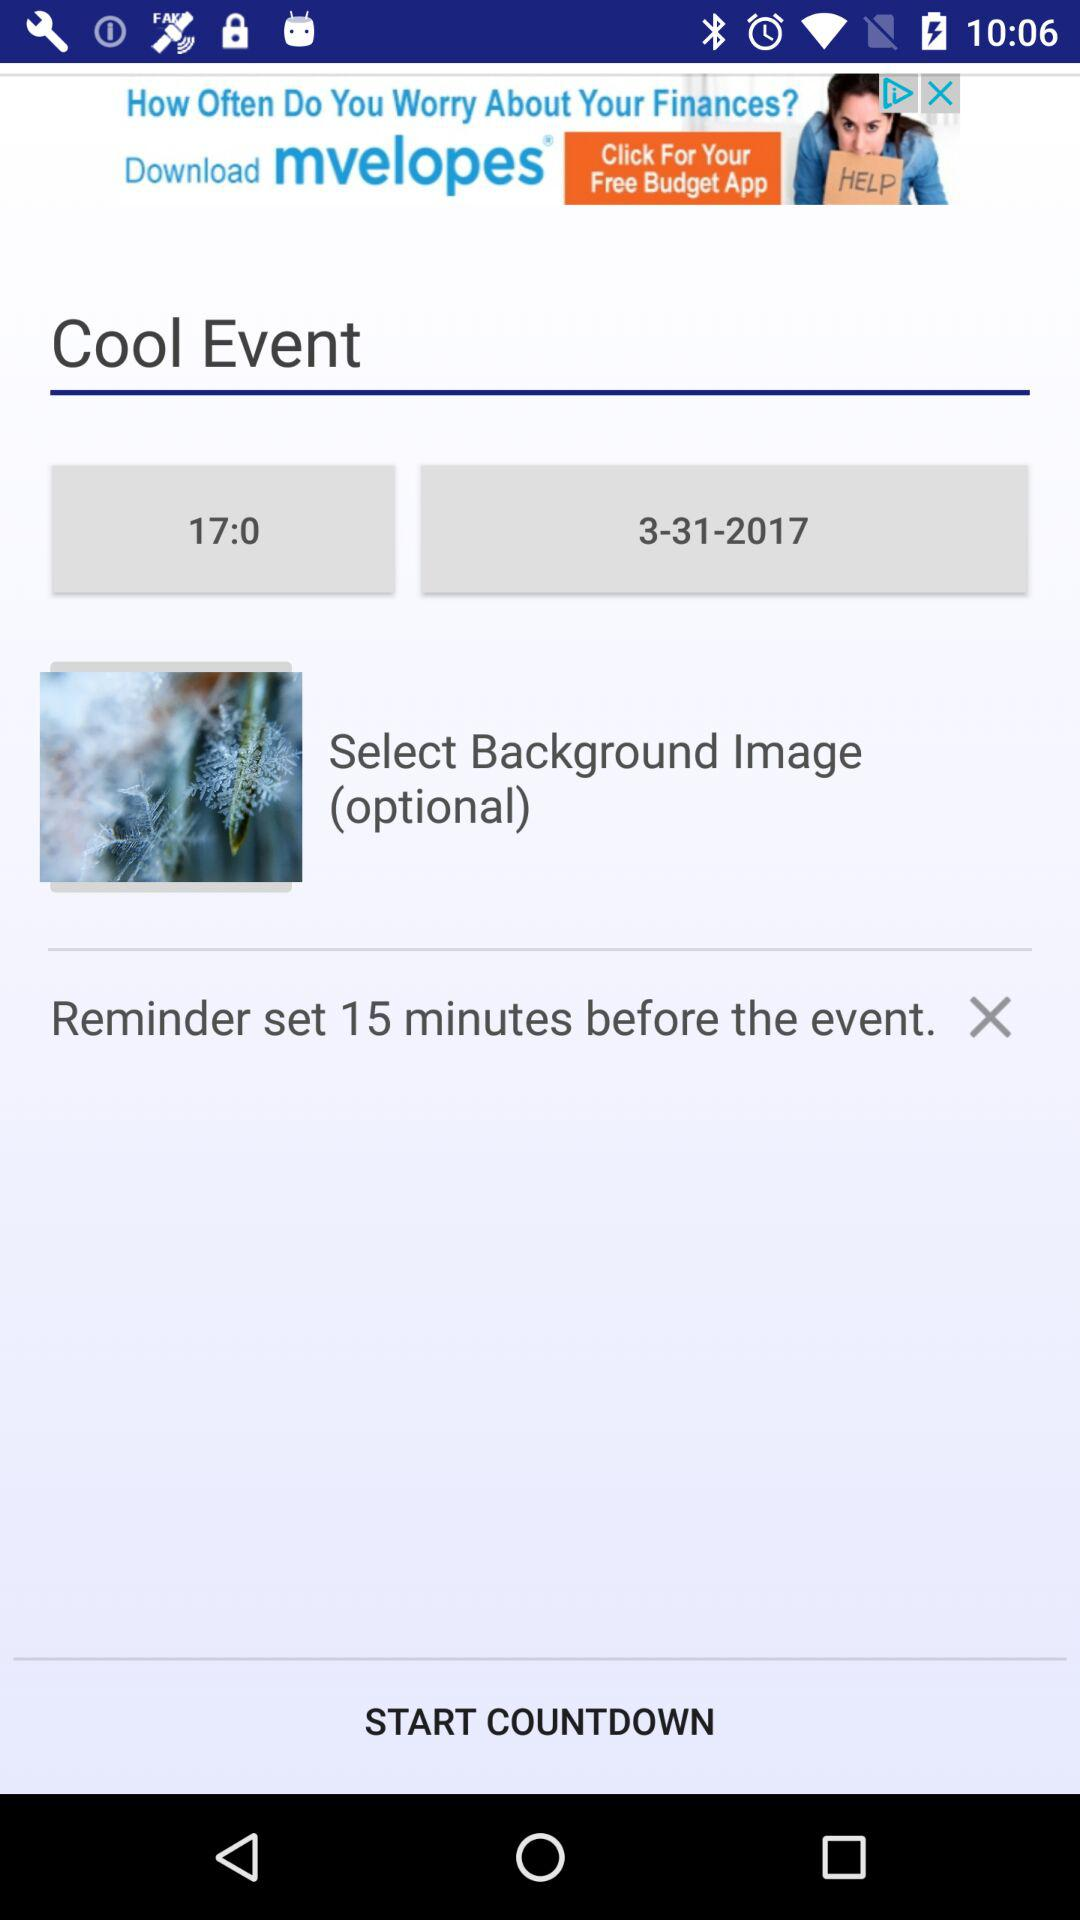What is the date of the cool event? The date is March 31, 2017. 